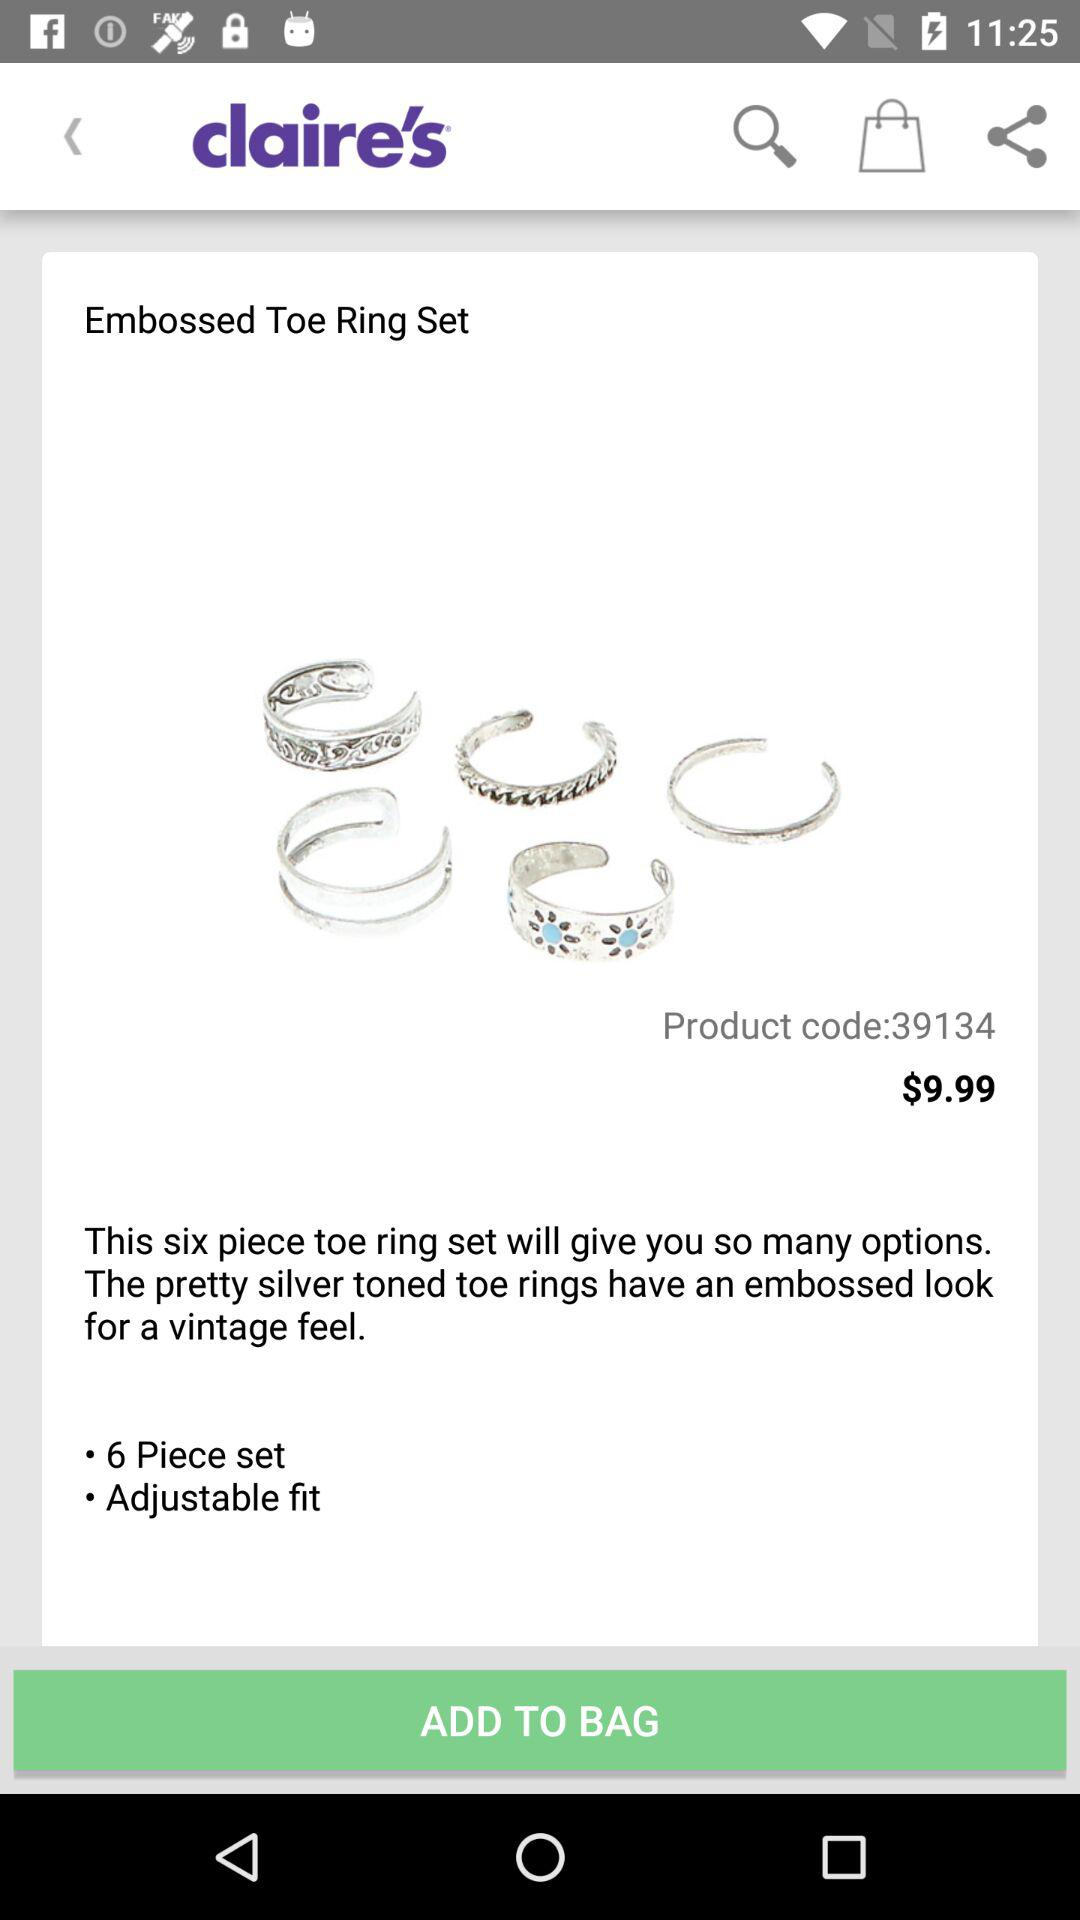How many pieces are available in one set? There are 6 pieces available in one set. 